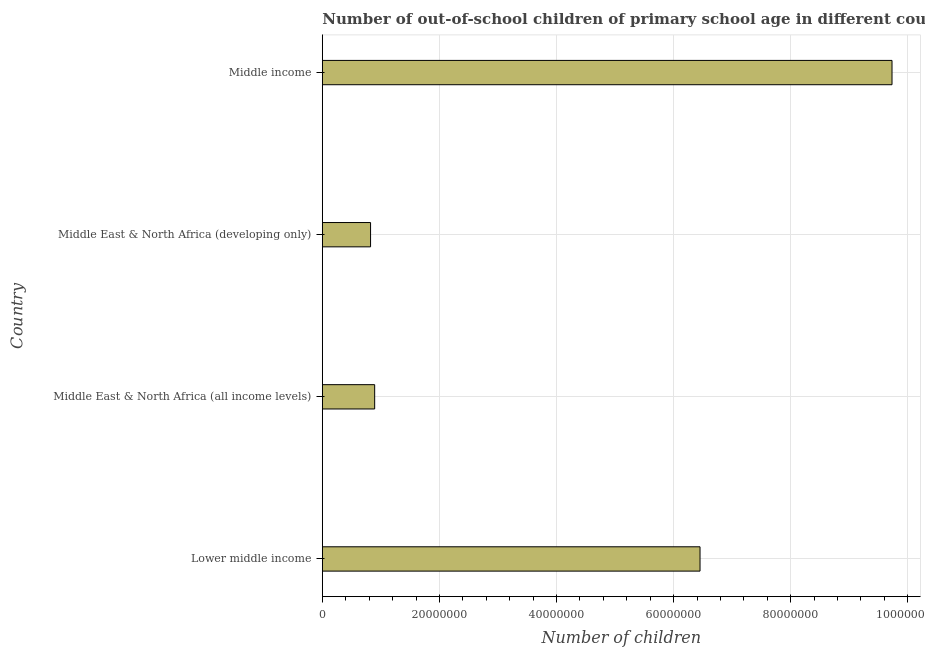Does the graph contain grids?
Give a very brief answer. Yes. What is the title of the graph?
Your answer should be very brief. Number of out-of-school children of primary school age in different countries. What is the label or title of the X-axis?
Give a very brief answer. Number of children. What is the label or title of the Y-axis?
Your answer should be compact. Country. What is the number of out-of-school children in Middle East & North Africa (all income levels)?
Make the answer very short. 8.94e+06. Across all countries, what is the maximum number of out-of-school children?
Offer a terse response. 9.73e+07. Across all countries, what is the minimum number of out-of-school children?
Offer a very short reply. 8.24e+06. In which country was the number of out-of-school children maximum?
Your answer should be very brief. Middle income. In which country was the number of out-of-school children minimum?
Offer a very short reply. Middle East & North Africa (developing only). What is the sum of the number of out-of-school children?
Ensure brevity in your answer.  1.79e+08. What is the difference between the number of out-of-school children in Lower middle income and Middle income?
Give a very brief answer. -3.28e+07. What is the average number of out-of-school children per country?
Your answer should be very brief. 4.47e+07. What is the median number of out-of-school children?
Ensure brevity in your answer.  3.67e+07. What is the ratio of the number of out-of-school children in Lower middle income to that in Middle East & North Africa (developing only)?
Provide a succinct answer. 7.83. Is the difference between the number of out-of-school children in Middle East & North Africa (all income levels) and Middle East & North Africa (developing only) greater than the difference between any two countries?
Your answer should be very brief. No. What is the difference between the highest and the second highest number of out-of-school children?
Keep it short and to the point. 3.28e+07. Is the sum of the number of out-of-school children in Middle East & North Africa (all income levels) and Middle income greater than the maximum number of out-of-school children across all countries?
Give a very brief answer. Yes. What is the difference between the highest and the lowest number of out-of-school children?
Your answer should be compact. 8.91e+07. In how many countries, is the number of out-of-school children greater than the average number of out-of-school children taken over all countries?
Give a very brief answer. 2. Are all the bars in the graph horizontal?
Your answer should be very brief. Yes. What is the difference between two consecutive major ticks on the X-axis?
Keep it short and to the point. 2.00e+07. Are the values on the major ticks of X-axis written in scientific E-notation?
Your response must be concise. No. What is the Number of children of Lower middle income?
Offer a very short reply. 6.45e+07. What is the Number of children in Middle East & North Africa (all income levels)?
Make the answer very short. 8.94e+06. What is the Number of children in Middle East & North Africa (developing only)?
Your answer should be very brief. 8.24e+06. What is the Number of children of Middle income?
Give a very brief answer. 9.73e+07. What is the difference between the Number of children in Lower middle income and Middle East & North Africa (all income levels)?
Keep it short and to the point. 5.56e+07. What is the difference between the Number of children in Lower middle income and Middle East & North Africa (developing only)?
Offer a terse response. 5.63e+07. What is the difference between the Number of children in Lower middle income and Middle income?
Offer a very short reply. -3.28e+07. What is the difference between the Number of children in Middle East & North Africa (all income levels) and Middle East & North Africa (developing only)?
Ensure brevity in your answer.  7.01e+05. What is the difference between the Number of children in Middle East & North Africa (all income levels) and Middle income?
Give a very brief answer. -8.84e+07. What is the difference between the Number of children in Middle East & North Africa (developing only) and Middle income?
Offer a very short reply. -8.91e+07. What is the ratio of the Number of children in Lower middle income to that in Middle East & North Africa (all income levels)?
Provide a short and direct response. 7.22. What is the ratio of the Number of children in Lower middle income to that in Middle East & North Africa (developing only)?
Keep it short and to the point. 7.83. What is the ratio of the Number of children in Lower middle income to that in Middle income?
Provide a succinct answer. 0.66. What is the ratio of the Number of children in Middle East & North Africa (all income levels) to that in Middle East & North Africa (developing only)?
Your answer should be compact. 1.08. What is the ratio of the Number of children in Middle East & North Africa (all income levels) to that in Middle income?
Give a very brief answer. 0.09. What is the ratio of the Number of children in Middle East & North Africa (developing only) to that in Middle income?
Provide a short and direct response. 0.09. 